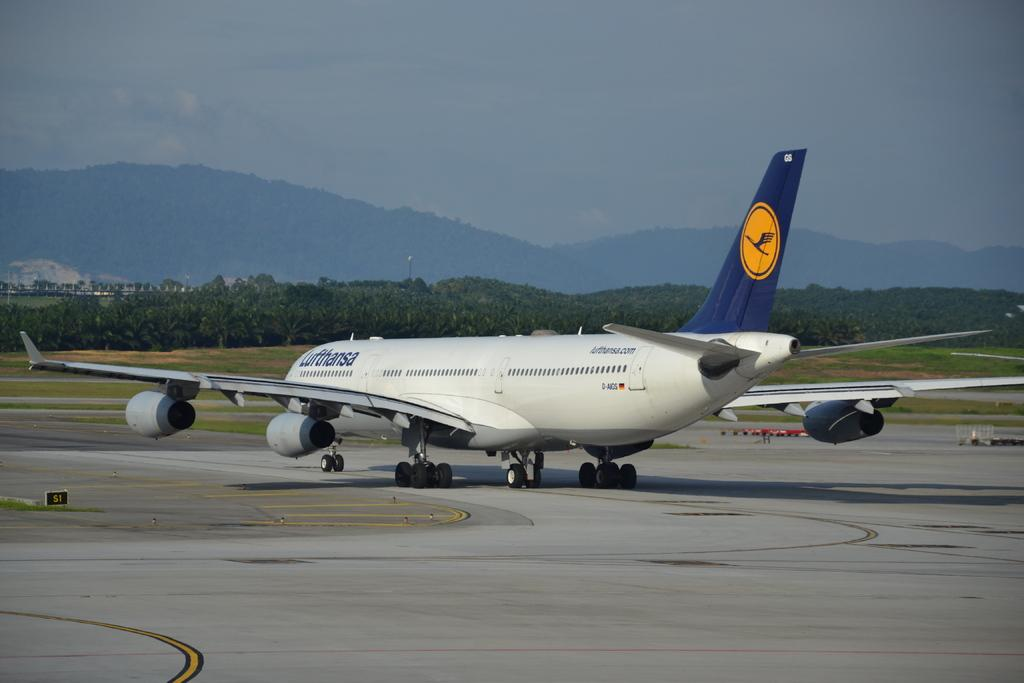What is the main subject of the image? The main subject of the image is an aeroplane on the runway. What can be seen in the background of the image? There are mountains and trees in the background of the image. What is visible at the top of the image? The sky is visible at the top of the image. Can you tell me how many crates are stacked next to the aeroplane in the image? There are no crates present in the image; it only features an aeroplane on the runway, mountains, trees, and the sky. 